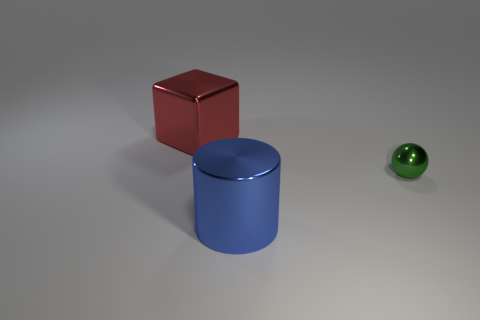Add 2 cyan matte objects. How many objects exist? 5 Subtract all spheres. How many objects are left? 2 Add 1 red blocks. How many red blocks are left? 2 Add 3 red metallic blocks. How many red metallic blocks exist? 4 Subtract 0 blue spheres. How many objects are left? 3 Subtract all blue balls. Subtract all cubes. How many objects are left? 2 